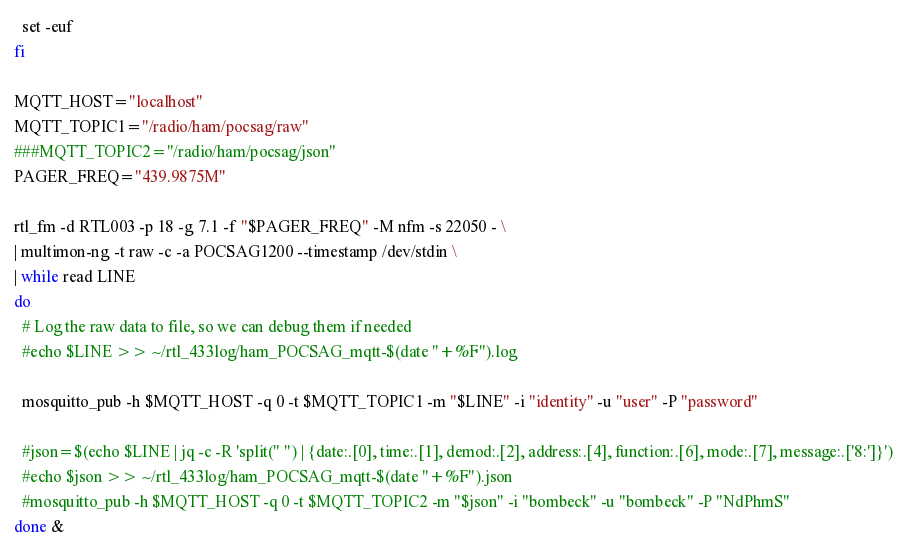Convert code to text. <code><loc_0><loc_0><loc_500><loc_500><_Bash_>  set -euf
fi

MQTT_HOST="localhost"
MQTT_TOPIC1="/radio/ham/pocsag/raw"
###MQTT_TOPIC2="/radio/ham/pocsag/json"
PAGER_FREQ="439.9875M"

rtl_fm -d RTL003 -p 18 -g 7.1 -f "$PAGER_FREQ" -M nfm -s 22050 - \
| multimon-ng -t raw -c -a POCSAG1200 --timestamp /dev/stdin \
| while read LINE
do
  # Log the raw data to file, so we can debug them if needed
  #echo $LINE >> ~/rtl_433log/ham_POCSAG_mqtt-$(date "+%F").log

  mosquitto_pub -h $MQTT_HOST -q 0 -t $MQTT_TOPIC1 -m "$LINE" -i "identity" -u "user" -P "password"

  #json=$(echo $LINE | jq -c -R 'split(" ") | {date:.[0], time:.[1], demod:.[2], address:.[4], function:.[6], mode:.[7], message:.['8:']}')
  #echo $json >> ~/rtl_433log/ham_POCSAG_mqtt-$(date "+%F").json
  #mosquitto_pub -h $MQTT_HOST -q 0 -t $MQTT_TOPIC2 -m "$json" -i "bombeck" -u "bombeck" -P "NdPhmS"
done &
</code> 